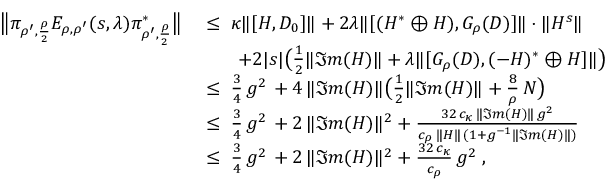<formula> <loc_0><loc_0><loc_500><loc_500>\begin{array} { r l } { \left \| \pi _ { \rho ^ { \prime } , \frac { \rho } { 2 } } E _ { \rho , \rho ^ { \prime } } ( s , \lambda ) \pi _ { \rho ^ { \prime } , \frac { \rho } { 2 } } ^ { * } \right \| } & { \, \leq \, \kappa \| [ H , D _ { 0 } ] \| + 2 \lambda \| [ ( H ^ { * } \oplus H ) , G _ { \rho } ( D ) ] \| \cdot \| H ^ { s } \| } \\ & { \quad + 2 | s | \left ( \frac { 1 } { 2 } \| \Im m ( H ) \| + { \lambda \| [ G _ { \rho } ( D ) } , ( - H ) ^ { * } \oplus H ] \| \right ) } \\ & { \, \leq \, \frac { 3 } { 4 } \, g ^ { 2 } \, + { 4 \, \| \Im m ( H ) \| \left ( \frac { 1 } { 2 } \| \Im m ( H ) \| + \frac { 8 } { \rho } \, N \right ) } } \\ & { \, \leq \, \frac { 3 } { 4 } \, g ^ { 2 } \, + 2 \, \| \Im m ( H ) \| ^ { 2 } + \frac { 3 2 \, c _ { \kappa } \, \| \Im m ( H ) \| \, g ^ { 2 } } { c _ { \rho } \, \| H \| \, ( 1 + g ^ { - 1 } \| \Im m ( H ) \| ) } } \\ & { \, \leq \, \frac { 3 } { 4 } \, g ^ { 2 } \, + 2 \, \| \Im m ( H ) \| ^ { 2 } + { \frac { 3 2 \, c _ { \kappa } } { c _ { \rho } } \, g ^ { 2 } } \, , } \end{array}</formula> 